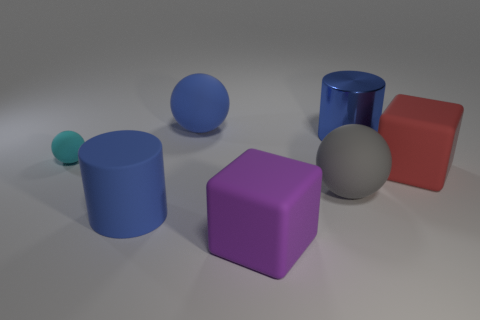What is the size of the object behind the blue thing on the right side of the big purple matte thing?
Your answer should be compact. Large. There is a cyan sphere that is made of the same material as the red block; what size is it?
Your answer should be very brief. Small. There is a matte thing that is both in front of the gray ball and behind the purple thing; what is its shape?
Offer a very short reply. Cylinder. Is the number of large blue things on the right side of the big shiny cylinder the same as the number of metallic things?
Provide a succinct answer. No. What number of things are either tiny cyan objects or spheres in front of the big blue rubber sphere?
Your answer should be compact. 2. Are there any other things of the same shape as the large metallic object?
Your response must be concise. Yes. Are there an equal number of blue cylinders on the right side of the matte cylinder and large blue cylinders that are to the right of the shiny object?
Your answer should be very brief. No. Is there anything else that has the same size as the cyan rubber thing?
Offer a terse response. No. What number of yellow objects are cubes or large things?
Give a very brief answer. 0. How many blue balls are the same size as the blue shiny thing?
Make the answer very short. 1. 